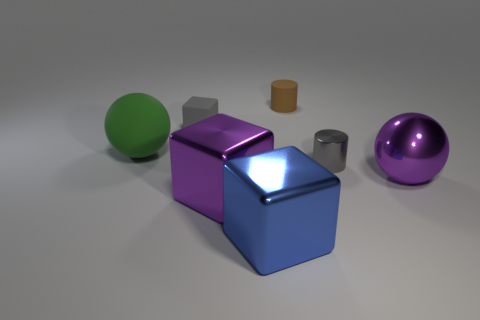Add 2 tiny cyan objects. How many objects exist? 9 Subtract all purple metal cubes. How many cubes are left? 2 Subtract 1 purple cubes. How many objects are left? 6 Subtract all cubes. How many objects are left? 4 Subtract 2 spheres. How many spheres are left? 0 Subtract all gray blocks. Subtract all cyan cylinders. How many blocks are left? 2 Subtract all cyan cubes. How many purple spheres are left? 1 Subtract all large blue cylinders. Subtract all tiny cylinders. How many objects are left? 5 Add 5 small gray shiny objects. How many small gray shiny objects are left? 6 Add 7 tiny yellow rubber cylinders. How many tiny yellow rubber cylinders exist? 7 